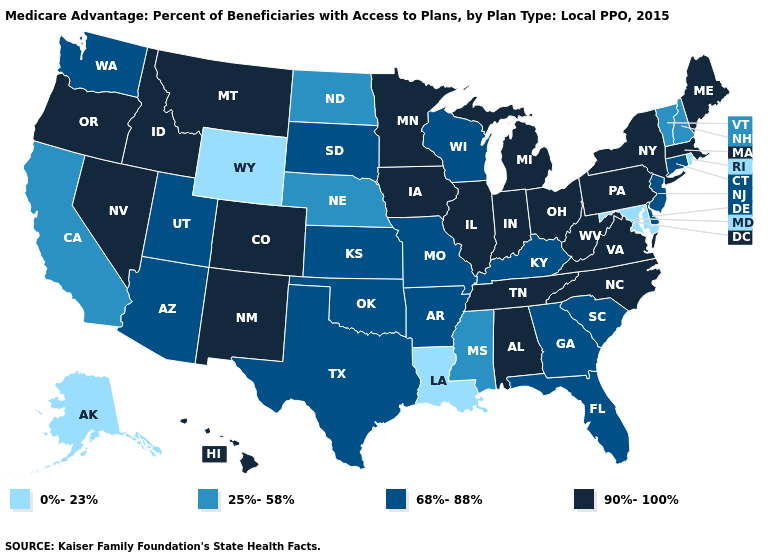Does Illinois have the lowest value in the USA?
Be succinct. No. Name the states that have a value in the range 68%-88%?
Keep it brief. Connecticut, Delaware, Florida, Georgia, Kansas, Kentucky, Missouri, New Jersey, Oklahoma, South Carolina, South Dakota, Texas, Utah, Washington, Wisconsin, Arkansas, Arizona. Name the states that have a value in the range 90%-100%?
Write a very short answer. Colorado, Hawaii, Iowa, Idaho, Illinois, Indiana, Massachusetts, Maine, Michigan, Minnesota, Montana, North Carolina, New Mexico, Nevada, New York, Ohio, Oregon, Pennsylvania, Tennessee, Virginia, West Virginia, Alabama. What is the value of Arizona?
Short answer required. 68%-88%. Does Mississippi have a lower value than Alaska?
Short answer required. No. What is the lowest value in states that border West Virginia?
Quick response, please. 0%-23%. Does the map have missing data?
Short answer required. No. Among the states that border South Carolina , does North Carolina have the highest value?
Keep it brief. Yes. Does the first symbol in the legend represent the smallest category?
Quick response, please. Yes. What is the value of Michigan?
Concise answer only. 90%-100%. What is the value of Oklahoma?
Give a very brief answer. 68%-88%. Does California have a higher value than Illinois?
Short answer required. No. Name the states that have a value in the range 25%-58%?
Be succinct. California, Mississippi, North Dakota, Nebraska, New Hampshire, Vermont. Does California have the same value as Montana?
Answer briefly. No. Which states have the lowest value in the USA?
Write a very short answer. Louisiana, Maryland, Rhode Island, Alaska, Wyoming. 